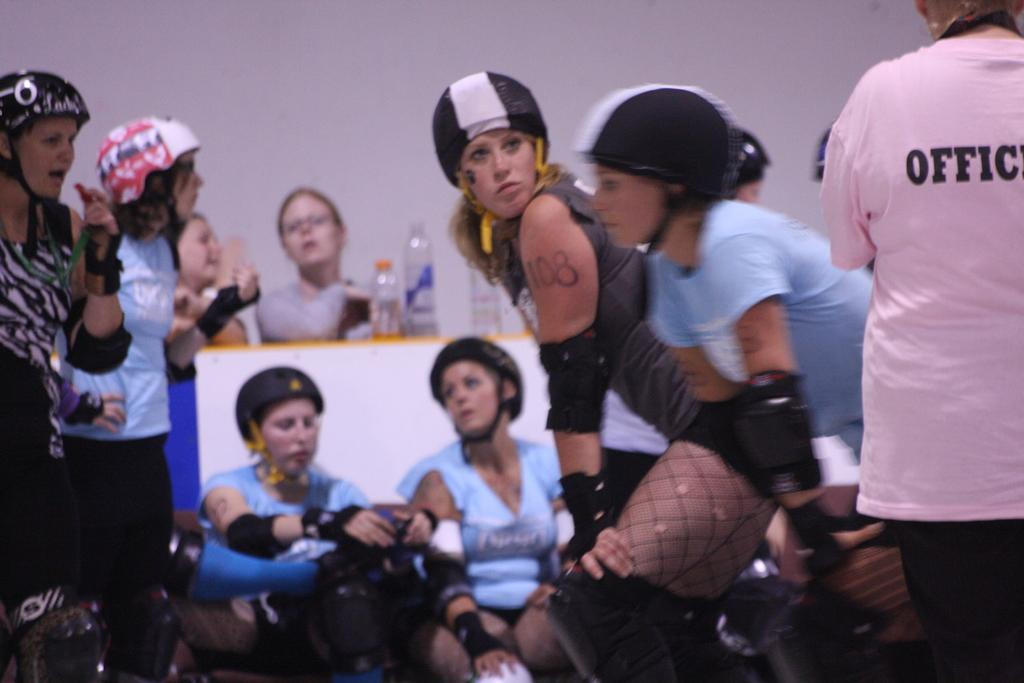What are the people in the image doing? Some people are standing, and others are sitting in the image. What protective gear can be seen in the image? Helmets are visible in the image. What type of containers are present on the surface in the image? Bottles are present on the surface in the image. Can you see any mist or fog in the image? There is no mention of mist or fog in the provided facts, so we cannot determine if it is present in the image. Is there a lake visible in the image? There is no mention of a lake in the provided facts, so we cannot determine if it is present in the image. 